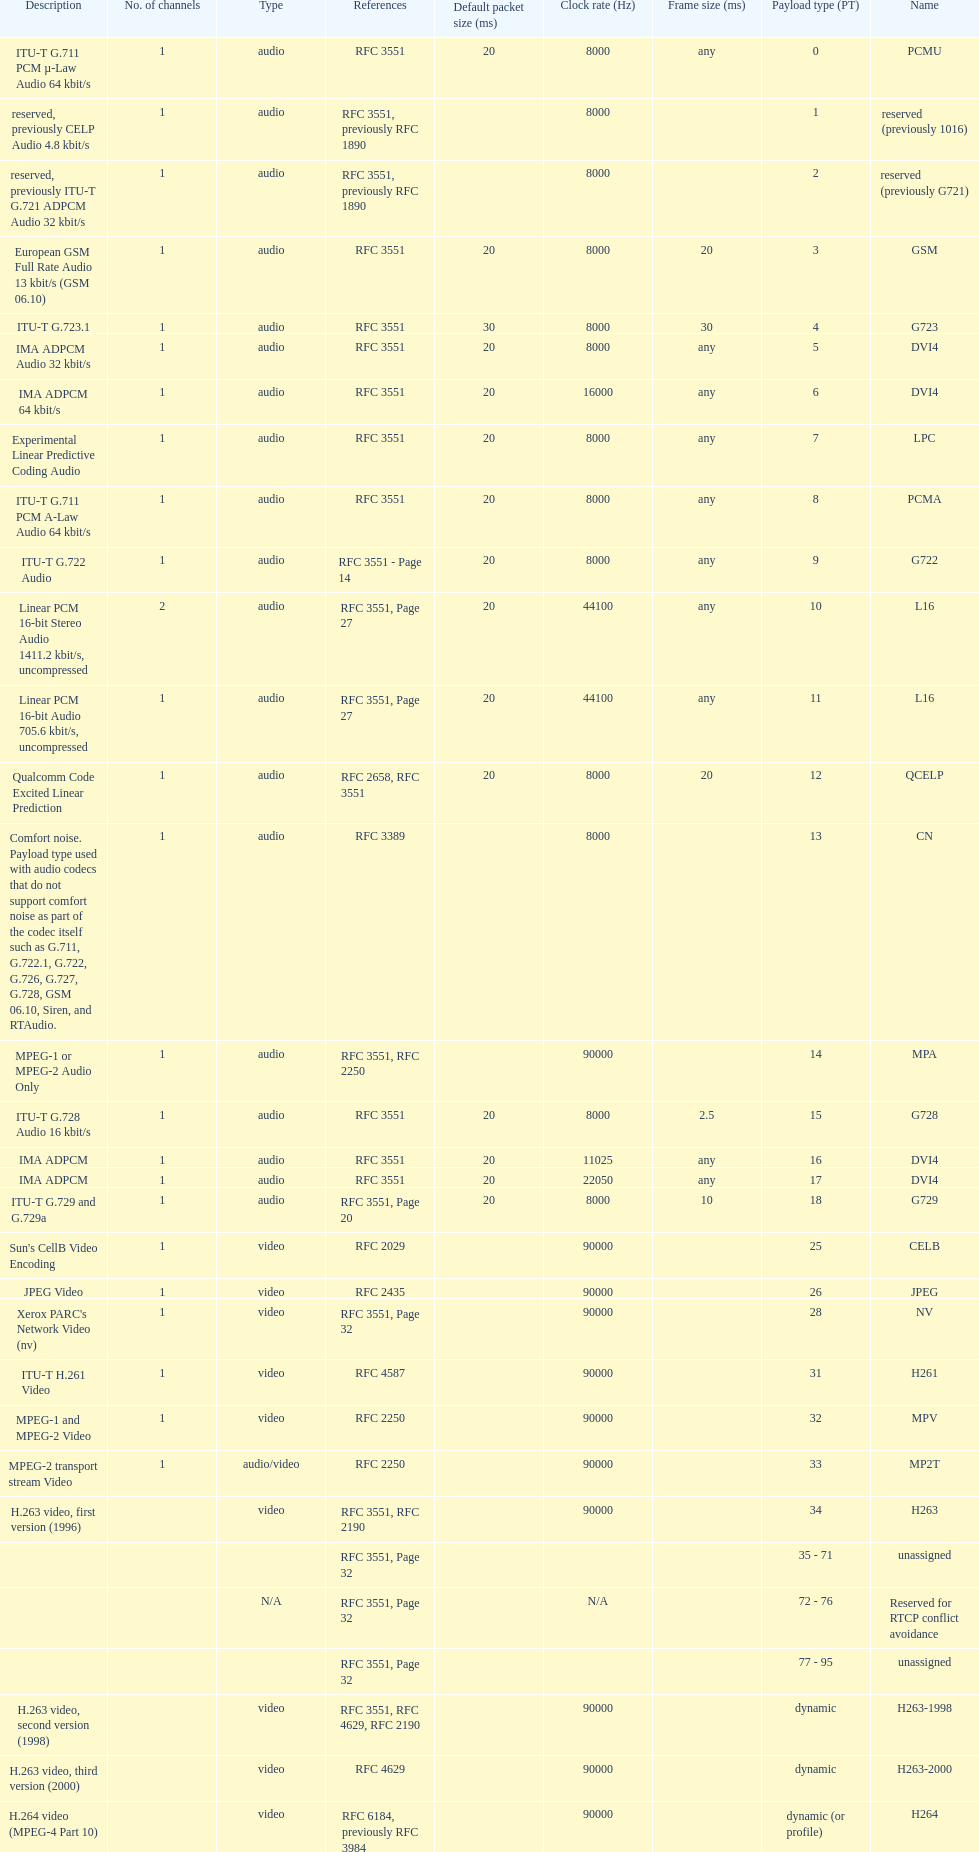What is the average number of channels? 1. I'm looking to parse the entire table for insights. Could you assist me with that? {'header': ['Description', 'No. of channels', 'Type', 'References', 'Default packet size (ms)', 'Clock rate (Hz)', 'Frame size (ms)', 'Payload type (PT)', 'Name'], 'rows': [['ITU-T G.711 PCM µ-Law Audio 64\xa0kbit/s', '1', 'audio', 'RFC 3551', '20', '8000', 'any', '0', 'PCMU'], ['reserved, previously CELP Audio 4.8\xa0kbit/s', '1', 'audio', 'RFC 3551, previously RFC 1890', '', '8000', '', '1', 'reserved (previously 1016)'], ['reserved, previously ITU-T G.721 ADPCM Audio 32\xa0kbit/s', '1', 'audio', 'RFC 3551, previously RFC 1890', '', '8000', '', '2', 'reserved (previously G721)'], ['European GSM Full Rate Audio 13\xa0kbit/s (GSM 06.10)', '1', 'audio', 'RFC 3551', '20', '8000', '20', '3', 'GSM'], ['ITU-T G.723.1', '1', 'audio', 'RFC 3551', '30', '8000', '30', '4', 'G723'], ['IMA ADPCM Audio 32\xa0kbit/s', '1', 'audio', 'RFC 3551', '20', '8000', 'any', '5', 'DVI4'], ['IMA ADPCM 64\xa0kbit/s', '1', 'audio', 'RFC 3551', '20', '16000', 'any', '6', 'DVI4'], ['Experimental Linear Predictive Coding Audio', '1', 'audio', 'RFC 3551', '20', '8000', 'any', '7', 'LPC'], ['ITU-T G.711 PCM A-Law Audio 64\xa0kbit/s', '1', 'audio', 'RFC 3551', '20', '8000', 'any', '8', 'PCMA'], ['ITU-T G.722 Audio', '1', 'audio', 'RFC 3551 - Page 14', '20', '8000', 'any', '9', 'G722'], ['Linear PCM 16-bit Stereo Audio 1411.2\xa0kbit/s, uncompressed', '2', 'audio', 'RFC 3551, Page 27', '20', '44100', 'any', '10', 'L16'], ['Linear PCM 16-bit Audio 705.6\xa0kbit/s, uncompressed', '1', 'audio', 'RFC 3551, Page 27', '20', '44100', 'any', '11', 'L16'], ['Qualcomm Code Excited Linear Prediction', '1', 'audio', 'RFC 2658, RFC 3551', '20', '8000', '20', '12', 'QCELP'], ['Comfort noise. Payload type used with audio codecs that do not support comfort noise as part of the codec itself such as G.711, G.722.1, G.722, G.726, G.727, G.728, GSM 06.10, Siren, and RTAudio.', '1', 'audio', 'RFC 3389', '', '8000', '', '13', 'CN'], ['MPEG-1 or MPEG-2 Audio Only', '1', 'audio', 'RFC 3551, RFC 2250', '', '90000', '', '14', 'MPA'], ['ITU-T G.728 Audio 16\xa0kbit/s', '1', 'audio', 'RFC 3551', '20', '8000', '2.5', '15', 'G728'], ['IMA ADPCM', '1', 'audio', 'RFC 3551', '20', '11025', 'any', '16', 'DVI4'], ['IMA ADPCM', '1', 'audio', 'RFC 3551', '20', '22050', 'any', '17', 'DVI4'], ['ITU-T G.729 and G.729a', '1', 'audio', 'RFC 3551, Page 20', '20', '8000', '10', '18', 'G729'], ["Sun's CellB Video Encoding", '1', 'video', 'RFC 2029', '', '90000', '', '25', 'CELB'], ['JPEG Video', '1', 'video', 'RFC 2435', '', '90000', '', '26', 'JPEG'], ["Xerox PARC's Network Video (nv)", '1', 'video', 'RFC 3551, Page 32', '', '90000', '', '28', 'NV'], ['ITU-T H.261 Video', '1', 'video', 'RFC 4587', '', '90000', '', '31', 'H261'], ['MPEG-1 and MPEG-2 Video', '1', 'video', 'RFC 2250', '', '90000', '', '32', 'MPV'], ['MPEG-2 transport stream Video', '1', 'audio/video', 'RFC 2250', '', '90000', '', '33', 'MP2T'], ['H.263 video, first version (1996)', '', 'video', 'RFC 3551, RFC 2190', '', '90000', '', '34', 'H263'], ['', '', '', 'RFC 3551, Page 32', '', '', '', '35 - 71', 'unassigned'], ['', '', 'N/A', 'RFC 3551, Page 32', '', 'N/A', '', '72 - 76', 'Reserved for RTCP conflict avoidance'], ['', '', '', 'RFC 3551, Page 32', '', '', '', '77 - 95', 'unassigned'], ['H.263 video, second version (1998)', '', 'video', 'RFC 3551, RFC 4629, RFC 2190', '', '90000', '', 'dynamic', 'H263-1998'], ['H.263 video, third version (2000)', '', 'video', 'RFC 4629', '', '90000', '', 'dynamic', 'H263-2000'], ['H.264 video (MPEG-4 Part 10)', '', 'video', 'RFC 6184, previously RFC 3984', '', '90000', '', 'dynamic (or profile)', 'H264'], ['Theora video', '', 'video', 'draft-barbato-avt-rtp-theora-01', '', '90000', '', 'dynamic (or profile)', 'theora'], ['Internet low Bitrate Codec 13.33 or 15.2\xa0kbit/s', '1', 'audio', 'RFC 3952', '20 or 30, respectively', '8000', '20 or 30', 'dynamic', 'iLBC'], ['ITU-T G.711.1, A-law', '', 'audio', 'RFC 5391', '', '16000', '5', 'dynamic', 'PCMA-WB'], ['ITU-T G.711.1, µ-law', '', 'audio', 'RFC 5391', '', '16000', '5', 'dynamic', 'PCMU-WB'], ['ITU-T G.718', '', 'audio', 'draft-ietf-avt-rtp-g718-03', '', '32000 (placeholder)', '20', 'dynamic', 'G718'], ['ITU-T G.719', '(various)', 'audio', 'RFC 5404', '', '48000', '20', 'dynamic', 'G719'], ['ITU-T G.722.1', '', 'audio', 'RFC 5577', '', '32000, 16000', '20', 'dynamic', 'G7221'], ['ITU-T G.726 audio with 16\xa0kbit/s', '1', 'audio', 'RFC 3551', '20', '8000', 'any', 'dynamic', 'G726-16'], ['ITU-T G.726 audio with 24\xa0kbit/s', '1', 'audio', 'RFC 3551', '20', '8000', 'any', 'dynamic', 'G726-24'], ['ITU-T G.726 audio with 32\xa0kbit/s', '1', 'audio', 'RFC 3551', '20', '8000', 'any', 'dynamic', 'G726-32'], ['ITU-T G.726 audio with 40\xa0kbit/s', '1', 'audio', 'RFC 3551', '20', '8000', 'any', 'dynamic', 'G726-40'], ['ITU-T G.729 Annex D', '1', 'audio', 'RFC 3551', '20', '8000', '10', 'dynamic', 'G729D'], ['ITU-T G.729 Annex E', '1', 'audio', 'RFC 3551', '20', '8000', '10', 'dynamic', 'G729E'], ['ITU-T G.729.1', '', 'audio', 'RFC 4749', '', '16000', '20', 'dynamic', 'G7291'], ['ITU-T GSM-EFR (GSM 06.60)', '1', 'audio', 'RFC 3551', '20', '8000', '20', 'dynamic', 'GSM-EFR'], ['ITU-T GSM-HR (GSM 06.20)', '1', 'audio', 'RFC 5993', '', '8000', '20', 'dynamic', 'GSM-HR-08'], ['Adaptive Multi-Rate audio', '(various)', 'audio', 'RFC 4867', '', '8000', '20', 'dynamic (or profile)', 'AMR'], ['Adaptive Multi-Rate Wideband audio (ITU-T G.722.2)', '(various)', 'audio', 'RFC 4867', '', '16000', '20', 'dynamic (or profile)', 'AMR-WB'], ['Extended Adaptive Multi Rate – WideBand audio', '1, 2 or omit', 'audio', 'RFC 4352', '', '72000', '80 (super-frame; internally divided in to transport frames of 13.33, 14.22, 15, 16, 17.78, 20, 21.33, 24, 26.67, 30, 35.55, or 40)', 'dynamic (or profile)', 'AMR-WB+'], ['RTP Payload Format for Vorbis Encoded Audio', '(various)', 'audio', 'RFC 5215', "as many Vorbis packets as fit within the path MTU, unless it exceeds an application's desired transmission latency", 'any (must be a multiple of sample rate)', '', 'dynamic (or profile)', 'vorbis'], ['RTP Payload Format for Opus Speech and Audio Codec', '1, 2', 'audio', 'draft', '20, minimum allowed value 3 (rounded from 2.5), maximum allowed value 120 (allowed values are 3, 5, 10, 20, 40, or 60 or an arbitrary multiple of Opus frame sizes rounded up to the next full integer value up to a maximum value of 120)', '48000', '2.5, 5, 10, 20, 40, or 60', 'dynamic (or profile)', 'opus'], ['RTP Payload Format for the Speex Codec', '1', 'audio', 'RFC 5574', '', '8000, 16000 or 32000', '20', 'dynamic (or profile)', 'speex'], ['A More Loss-Tolerant RTP Payload Format for MP3 Audio', '', 'audio', 'RFC 5219', '', '90000', '', 'dynamic (96-127)', 'mpa-robust'], ['RTP Payload Format for MPEG-4 Audio', '', 'audio', 'RFC 6416 (previously RFC 3016)', 'recommended same as frame size', '90000 or others', '', 'dynamic (or profile)', 'MP4A-LATM'], ['RTP Payload Format for MPEG-4 Visual', '', 'video', 'RFC 6416 (previously RFC 3016)', 'recommended same as frame size', '90000 or others', '', 'dynamic (or profile)', 'MP4V-ES'], ['RTP Payload Format for Transport of MPEG-4 Elementary Streams', '', 'audio/video', 'RFC 3640', '', '90000 or other', '', 'dynamic (or profile)', 'mpeg4-generic'], ['RTP Payload Format for Transport of VP8 Streams', '', 'video', 'draft-ietf-payload-vp8-08', '', '90000', '', 'dynamic', 'VP8'], ['Linear PCM 8-bit audio with 128 offset', '(various)', 'audio', 'RFC 3551 Section 4.5.10 and Table 5', '20', '(various)', 'any', 'dynamic', 'L8'], ['IEC 61119 12-bit nonlinear audio', '(various)', 'audio', 'RFC 3190 Section 3', '20 (by analogy with L16)', '8000, 11025, 16000, 22050, 24000, 32000, 44100, 48000 or others', 'any', 'dynamic', 'DAT12'], ['Linear PCM 16-bit audio', '(various)', 'audio', 'RFC 3551 Section 4.5.11, RFC 2586', '20', '8000, 11025, 16000, 22050, 24000, 32000, 44100, 48000 or others', 'any', 'dynamic', 'L16'], ['Linear PCM 20-bit audio', '(various)', 'audio', 'RFC 3190 Section 4', '20 (by analogy with L16)', '8000, 11025, 16000, 22050, 24000, 32000, 44100, 48000 or others', 'any', 'dynamic', 'L20'], ['Linear PCM 24-bit audio', '(various)', 'audio', 'RFC 3190 Section 4', '20 (by analogy with L16)', '8000, 11025, 16000, 22050, 24000, 32000, 44100, 48000 or others', 'any', 'dynamic', 'L24']]} 